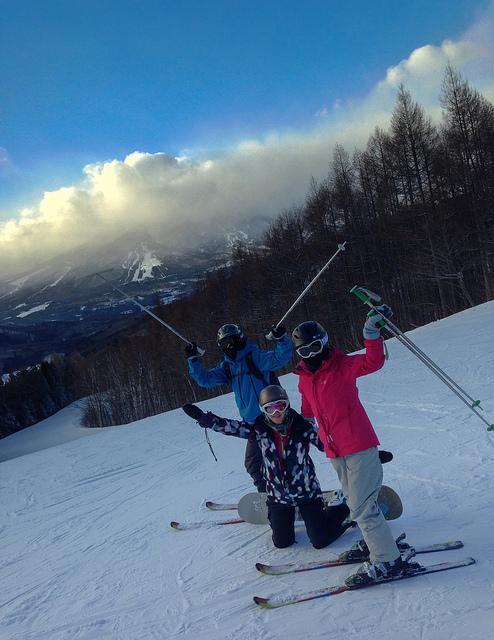How many people are skiing?
Give a very brief answer. 3. How many people are there?
Give a very brief answer. 3. 